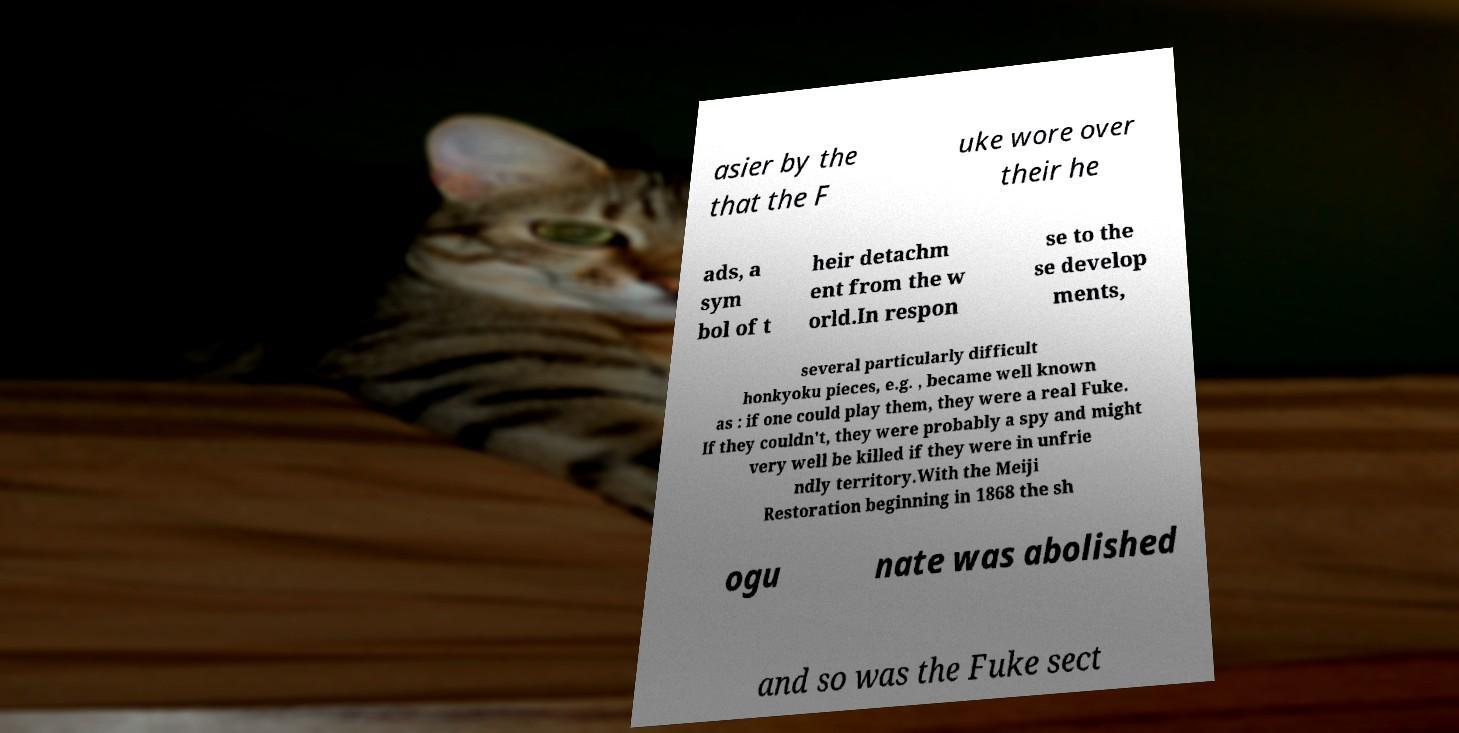What messages or text are displayed in this image? I need them in a readable, typed format. asier by the that the F uke wore over their he ads, a sym bol of t heir detachm ent from the w orld.In respon se to the se develop ments, several particularly difficult honkyoku pieces, e.g. , became well known as : if one could play them, they were a real Fuke. If they couldn't, they were probably a spy and might very well be killed if they were in unfrie ndly territory.With the Meiji Restoration beginning in 1868 the sh ogu nate was abolished and so was the Fuke sect 